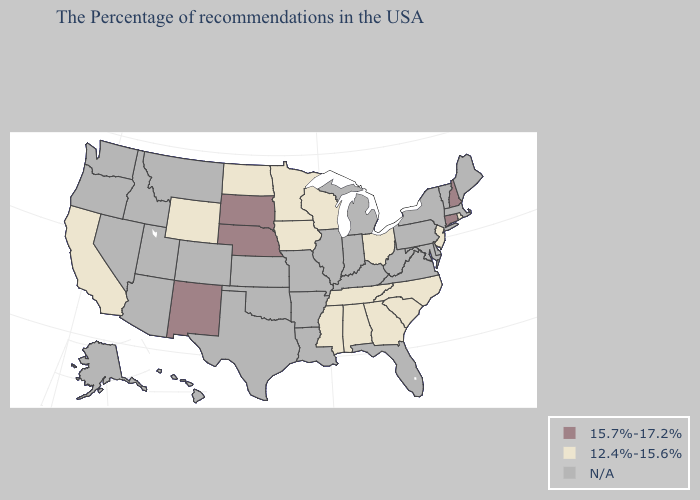Name the states that have a value in the range 15.7%-17.2%?
Answer briefly. New Hampshire, Connecticut, Nebraska, South Dakota, New Mexico. Name the states that have a value in the range N/A?
Write a very short answer. Maine, Massachusetts, Vermont, New York, Delaware, Maryland, Pennsylvania, Virginia, West Virginia, Florida, Michigan, Kentucky, Indiana, Illinois, Louisiana, Missouri, Arkansas, Kansas, Oklahoma, Texas, Colorado, Utah, Montana, Arizona, Idaho, Nevada, Washington, Oregon, Alaska, Hawaii. Name the states that have a value in the range 15.7%-17.2%?
Concise answer only. New Hampshire, Connecticut, Nebraska, South Dakota, New Mexico. Which states have the lowest value in the USA?
Short answer required. Rhode Island, New Jersey, North Carolina, South Carolina, Ohio, Georgia, Alabama, Tennessee, Wisconsin, Mississippi, Minnesota, Iowa, North Dakota, Wyoming, California. Among the states that border Connecticut , which have the lowest value?
Quick response, please. Rhode Island. What is the highest value in the USA?
Keep it brief. 15.7%-17.2%. What is the value of North Carolina?
Write a very short answer. 12.4%-15.6%. Which states have the lowest value in the Northeast?
Answer briefly. Rhode Island, New Jersey. Which states have the lowest value in the USA?
Keep it brief. Rhode Island, New Jersey, North Carolina, South Carolina, Ohio, Georgia, Alabama, Tennessee, Wisconsin, Mississippi, Minnesota, Iowa, North Dakota, Wyoming, California. Name the states that have a value in the range 15.7%-17.2%?
Write a very short answer. New Hampshire, Connecticut, Nebraska, South Dakota, New Mexico. What is the value of Oklahoma?
Give a very brief answer. N/A. What is the value of Ohio?
Keep it brief. 12.4%-15.6%. Name the states that have a value in the range 12.4%-15.6%?
Give a very brief answer. Rhode Island, New Jersey, North Carolina, South Carolina, Ohio, Georgia, Alabama, Tennessee, Wisconsin, Mississippi, Minnesota, Iowa, North Dakota, Wyoming, California. What is the value of Kentucky?
Answer briefly. N/A. 